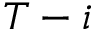Convert formula to latex. <formula><loc_0><loc_0><loc_500><loc_500>T - i</formula> 